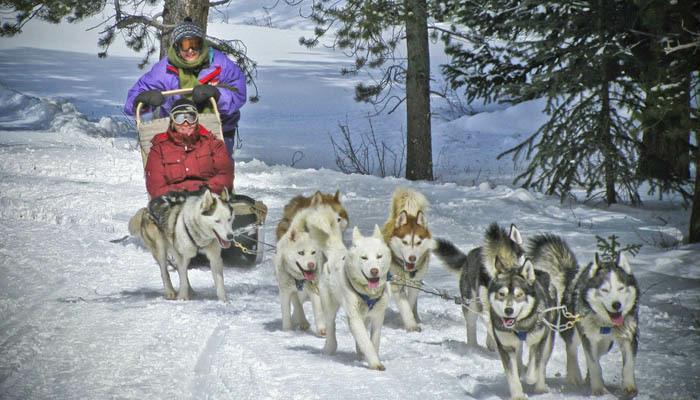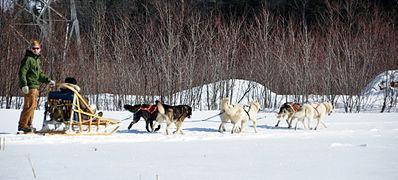The first image is the image on the left, the second image is the image on the right. For the images displayed, is the sentence "There are multiple persons being pulled by the dogs in the image on the left." factually correct? Answer yes or no. Yes. The first image is the image on the left, the second image is the image on the right. Analyze the images presented: Is the assertion "At least one rider wearing a fur-trimmed head covering is visible in one dog sled image, and the front-most sled in the other image has no seated passenger." valid? Answer yes or no. No. 